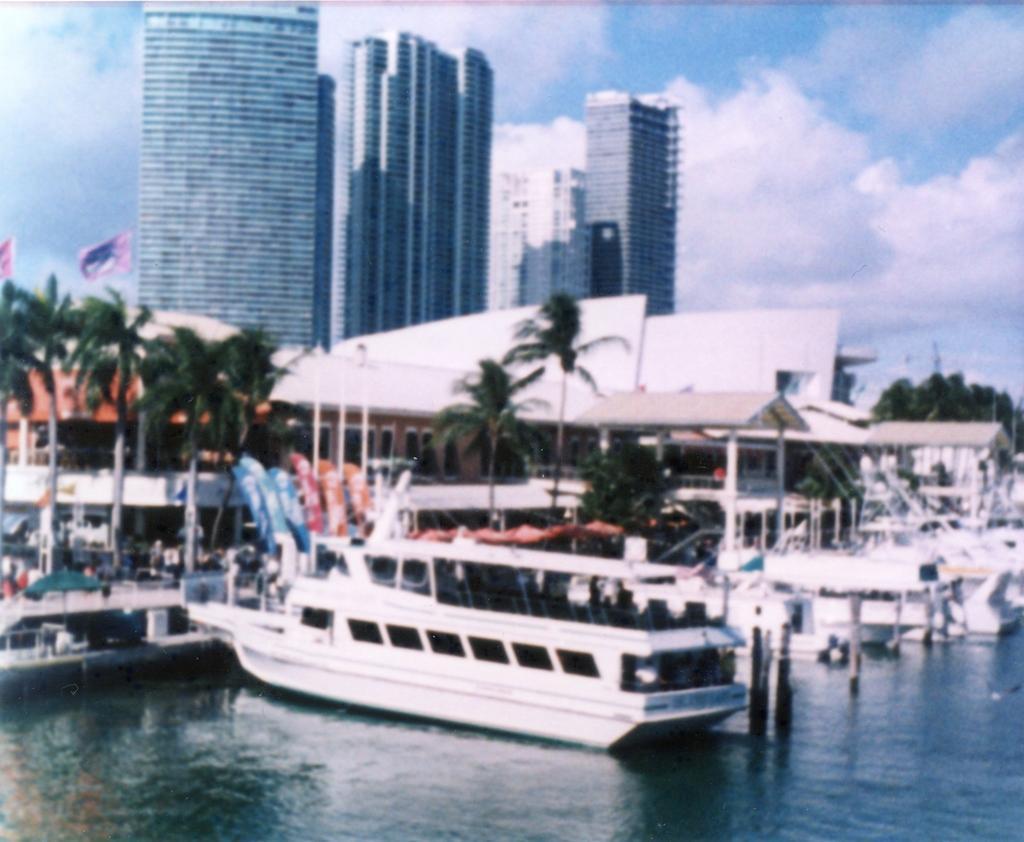Can you describe this image briefly? In this picture I can see few buildings, trees and few boats in the water and I can see couple of flags and a blue cloudy sky. 